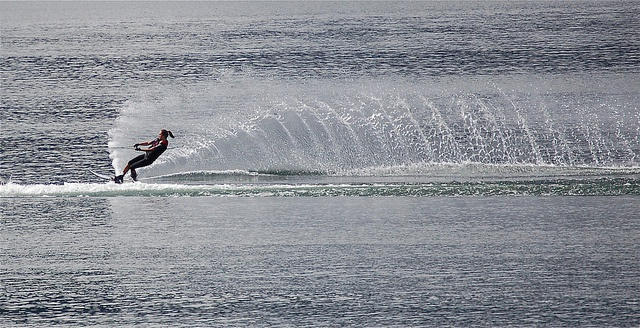Describe the objects in this image and their specific colors. I can see people in lightgray, black, gray, and darkgray tones in this image. 